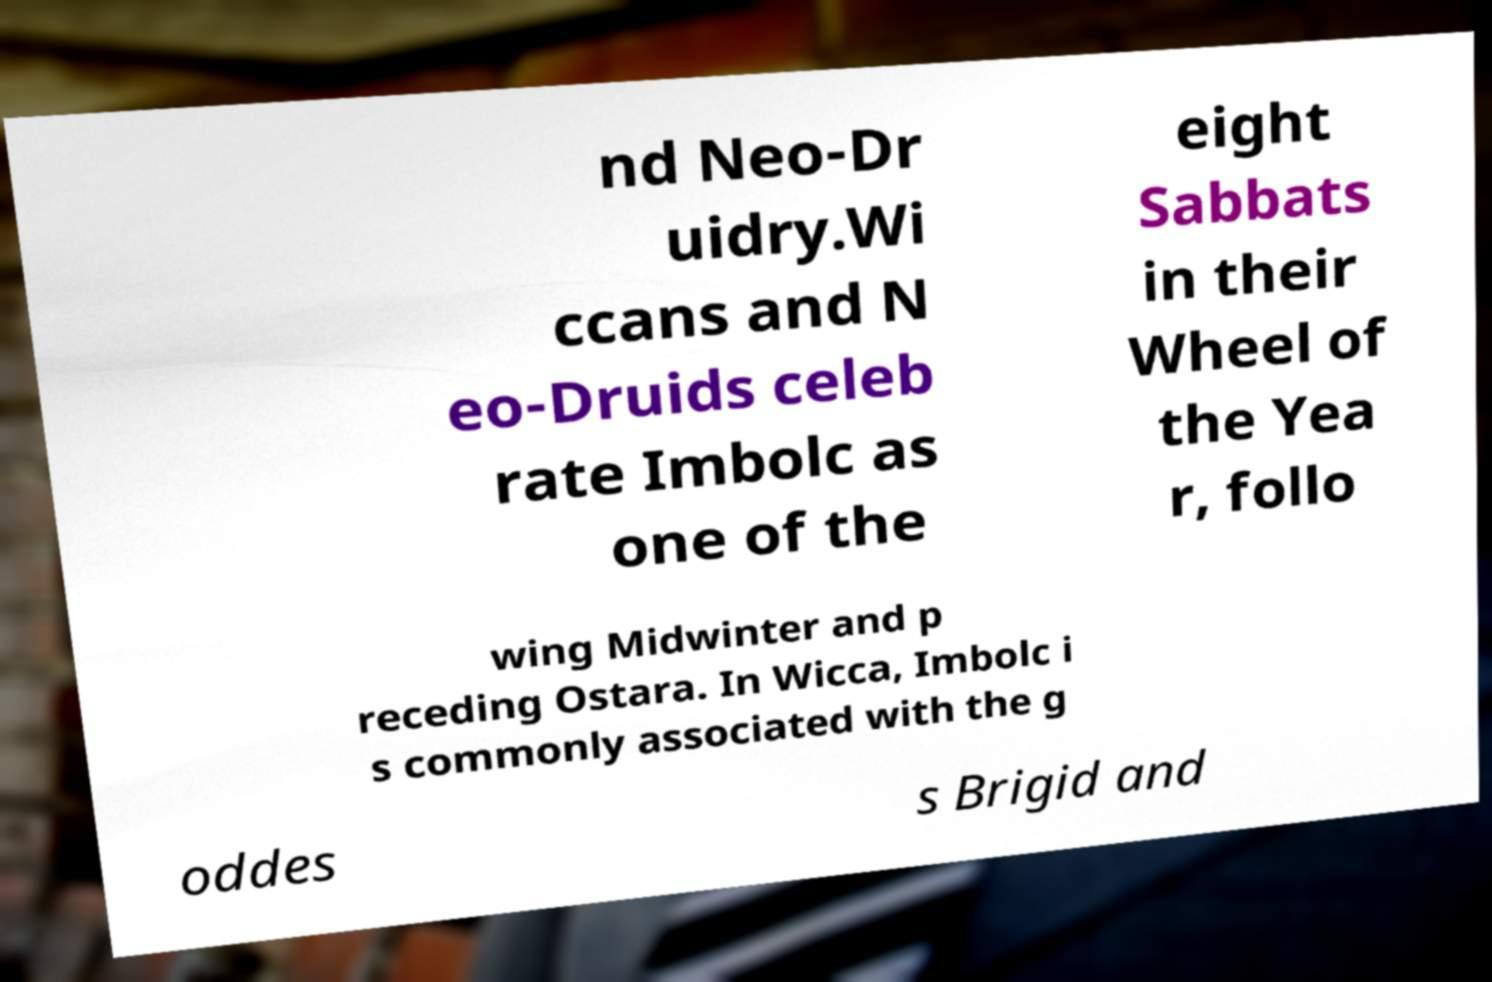Please identify and transcribe the text found in this image. nd Neo-Dr uidry.Wi ccans and N eo-Druids celeb rate Imbolc as one of the eight Sabbats in their Wheel of the Yea r, follo wing Midwinter and p receding Ostara. In Wicca, Imbolc i s commonly associated with the g oddes s Brigid and 